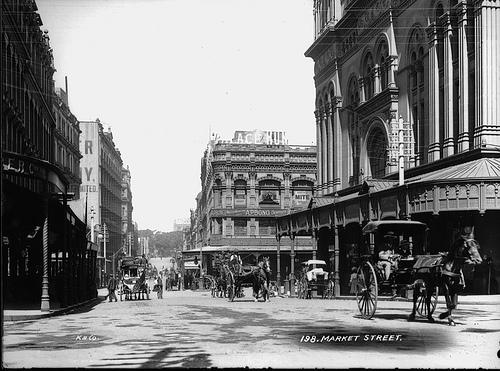Are there any cars on this street?
Concise answer only. No. Are there power poles along the road?
Give a very brief answer. No. How many animals shown?
Be succinct. 2. How many vehicles are shown?
Keep it brief. 4. How many horses are there?
Quick response, please. 2. 